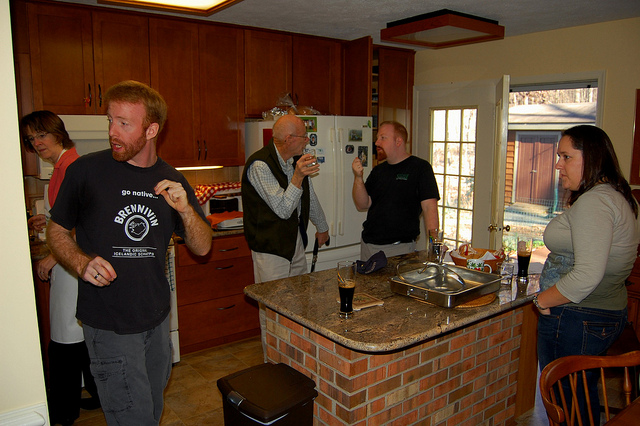Identify and read out the text in this image. BERNNIVIN 90 